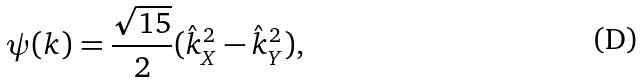Convert formula to latex. <formula><loc_0><loc_0><loc_500><loc_500>\psi ( { k } ) = \frac { \sqrt { 1 5 } } { 2 } ( \hat { k } _ { X } ^ { 2 } - \hat { k } _ { Y } ^ { 2 } ) ,</formula> 